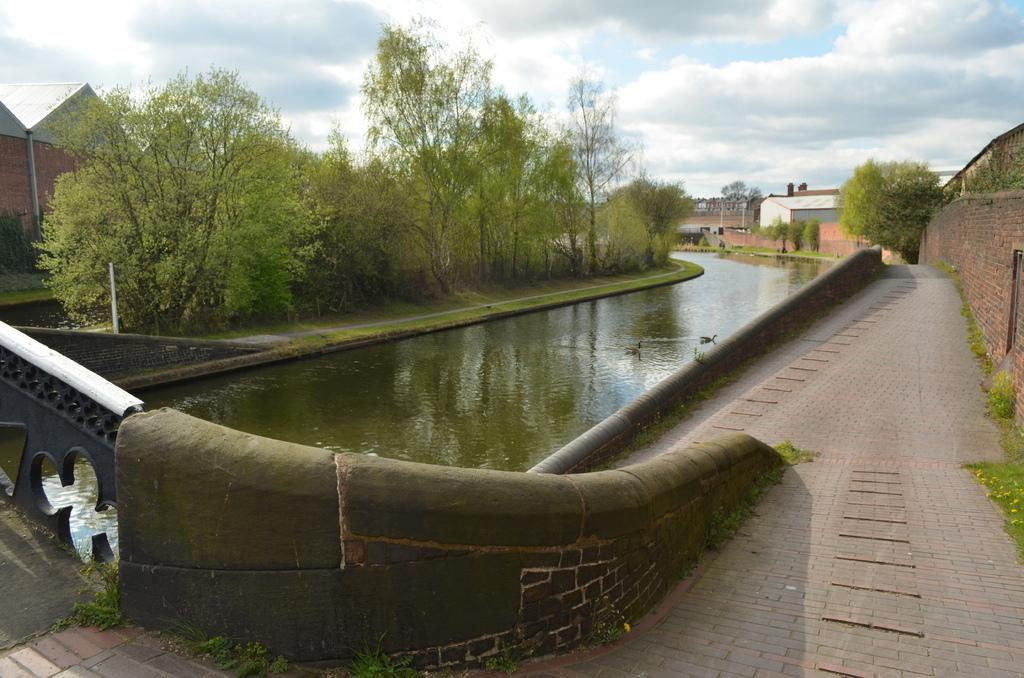What is the main feature in the center of the image? There is a canal in the center of the image. What can be seen in the canal? There are ducks in the canal. What type of vegetation is on the left side of the image? There are trees on the left side of the image. What structures are visible in the background of the image? There are sheds in the background of the image. What is visible in the sky in the background of the image? The sky is visible in the background of the image. What type of insect can be seen flying over the canal in the image? There is no insect visible in the image; it only shows ducks in the canal. What is the temperature like in the image? The image does not provide any information about the temperature, so it cannot be determined. 